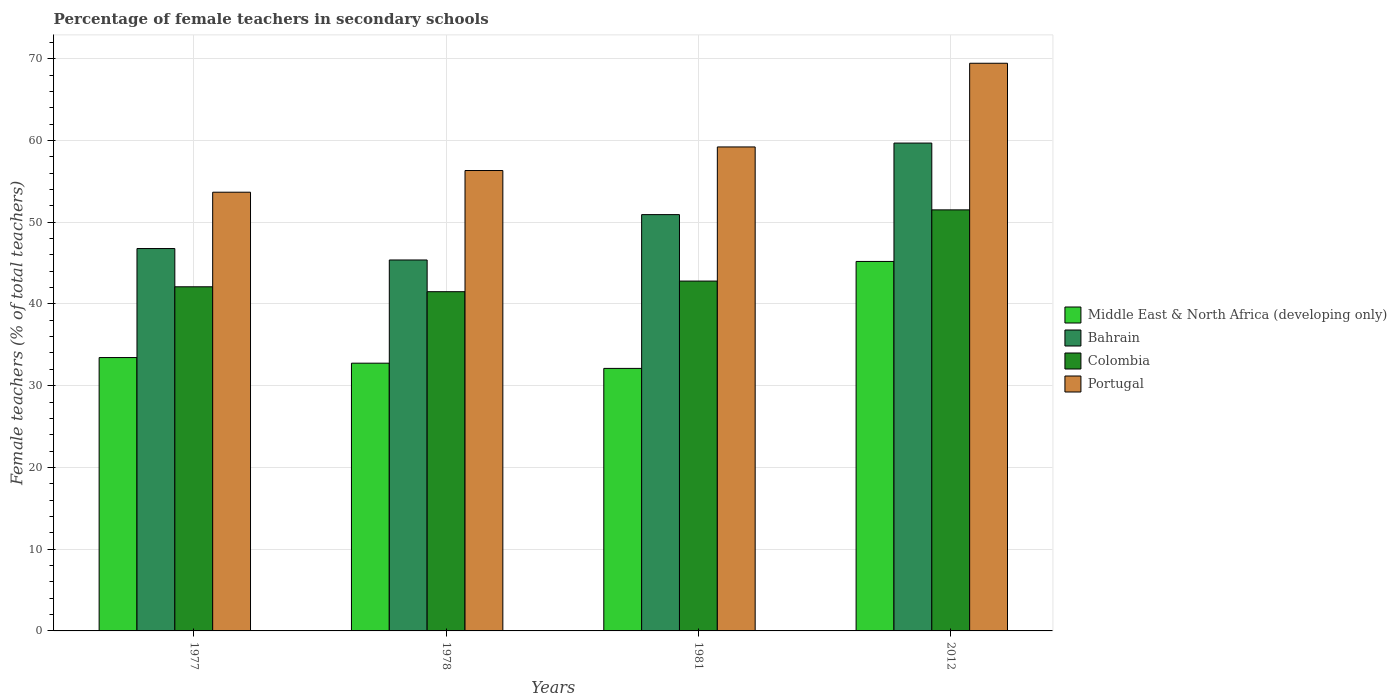How many different coloured bars are there?
Provide a succinct answer. 4. Are the number of bars per tick equal to the number of legend labels?
Provide a short and direct response. Yes. Are the number of bars on each tick of the X-axis equal?
Provide a short and direct response. Yes. How many bars are there on the 4th tick from the left?
Make the answer very short. 4. How many bars are there on the 3rd tick from the right?
Provide a succinct answer. 4. What is the label of the 2nd group of bars from the left?
Keep it short and to the point. 1978. In how many cases, is the number of bars for a given year not equal to the number of legend labels?
Your answer should be very brief. 0. What is the percentage of female teachers in Portugal in 2012?
Your answer should be compact. 69.45. Across all years, what is the maximum percentage of female teachers in Bahrain?
Your answer should be very brief. 59.68. Across all years, what is the minimum percentage of female teachers in Portugal?
Give a very brief answer. 53.67. In which year was the percentage of female teachers in Colombia maximum?
Ensure brevity in your answer.  2012. In which year was the percentage of female teachers in Colombia minimum?
Offer a very short reply. 1978. What is the total percentage of female teachers in Middle East & North Africa (developing only) in the graph?
Offer a terse response. 143.51. What is the difference between the percentage of female teachers in Colombia in 1978 and that in 2012?
Give a very brief answer. -10.01. What is the difference between the percentage of female teachers in Bahrain in 1981 and the percentage of female teachers in Portugal in 1978?
Offer a very short reply. -5.39. What is the average percentage of female teachers in Middle East & North Africa (developing only) per year?
Your answer should be very brief. 35.88. In the year 2012, what is the difference between the percentage of female teachers in Colombia and percentage of female teachers in Bahrain?
Provide a short and direct response. -8.17. In how many years, is the percentage of female teachers in Colombia greater than 30 %?
Give a very brief answer. 4. What is the ratio of the percentage of female teachers in Colombia in 1981 to that in 2012?
Make the answer very short. 0.83. Is the difference between the percentage of female teachers in Colombia in 1977 and 2012 greater than the difference between the percentage of female teachers in Bahrain in 1977 and 2012?
Give a very brief answer. Yes. What is the difference between the highest and the second highest percentage of female teachers in Portugal?
Offer a terse response. 10.24. What is the difference between the highest and the lowest percentage of female teachers in Middle East & North Africa (developing only)?
Provide a short and direct response. 13.08. Is it the case that in every year, the sum of the percentage of female teachers in Portugal and percentage of female teachers in Middle East & North Africa (developing only) is greater than the sum of percentage of female teachers in Bahrain and percentage of female teachers in Colombia?
Ensure brevity in your answer.  No. What does the 3rd bar from the left in 1981 represents?
Your answer should be compact. Colombia. Is it the case that in every year, the sum of the percentage of female teachers in Middle East & North Africa (developing only) and percentage of female teachers in Colombia is greater than the percentage of female teachers in Bahrain?
Make the answer very short. Yes. How many bars are there?
Your answer should be compact. 16. What is the difference between two consecutive major ticks on the Y-axis?
Your answer should be very brief. 10. What is the title of the graph?
Give a very brief answer. Percentage of female teachers in secondary schools. Does "Sint Maarten (Dutch part)" appear as one of the legend labels in the graph?
Keep it short and to the point. No. What is the label or title of the Y-axis?
Ensure brevity in your answer.  Female teachers (% of total teachers). What is the Female teachers (% of total teachers) of Middle East & North Africa (developing only) in 1977?
Give a very brief answer. 33.44. What is the Female teachers (% of total teachers) in Bahrain in 1977?
Your answer should be compact. 46.78. What is the Female teachers (% of total teachers) in Colombia in 1977?
Give a very brief answer. 42.1. What is the Female teachers (% of total teachers) in Portugal in 1977?
Your answer should be very brief. 53.67. What is the Female teachers (% of total teachers) of Middle East & North Africa (developing only) in 1978?
Ensure brevity in your answer.  32.75. What is the Female teachers (% of total teachers) of Bahrain in 1978?
Provide a succinct answer. 45.38. What is the Female teachers (% of total teachers) of Colombia in 1978?
Ensure brevity in your answer.  41.5. What is the Female teachers (% of total teachers) of Portugal in 1978?
Provide a short and direct response. 56.32. What is the Female teachers (% of total teachers) of Middle East & North Africa (developing only) in 1981?
Keep it short and to the point. 32.12. What is the Female teachers (% of total teachers) of Bahrain in 1981?
Your answer should be compact. 50.93. What is the Female teachers (% of total teachers) in Colombia in 1981?
Your answer should be very brief. 42.8. What is the Female teachers (% of total teachers) of Portugal in 1981?
Provide a short and direct response. 59.21. What is the Female teachers (% of total teachers) of Middle East & North Africa (developing only) in 2012?
Your answer should be compact. 45.2. What is the Female teachers (% of total teachers) of Bahrain in 2012?
Provide a short and direct response. 59.68. What is the Female teachers (% of total teachers) in Colombia in 2012?
Ensure brevity in your answer.  51.51. What is the Female teachers (% of total teachers) of Portugal in 2012?
Provide a succinct answer. 69.45. Across all years, what is the maximum Female teachers (% of total teachers) of Middle East & North Africa (developing only)?
Provide a short and direct response. 45.2. Across all years, what is the maximum Female teachers (% of total teachers) in Bahrain?
Provide a succinct answer. 59.68. Across all years, what is the maximum Female teachers (% of total teachers) of Colombia?
Provide a short and direct response. 51.51. Across all years, what is the maximum Female teachers (% of total teachers) of Portugal?
Offer a very short reply. 69.45. Across all years, what is the minimum Female teachers (% of total teachers) of Middle East & North Africa (developing only)?
Your response must be concise. 32.12. Across all years, what is the minimum Female teachers (% of total teachers) in Bahrain?
Give a very brief answer. 45.38. Across all years, what is the minimum Female teachers (% of total teachers) of Colombia?
Give a very brief answer. 41.5. Across all years, what is the minimum Female teachers (% of total teachers) in Portugal?
Provide a succinct answer. 53.67. What is the total Female teachers (% of total teachers) of Middle East & North Africa (developing only) in the graph?
Provide a short and direct response. 143.51. What is the total Female teachers (% of total teachers) of Bahrain in the graph?
Ensure brevity in your answer.  202.77. What is the total Female teachers (% of total teachers) of Colombia in the graph?
Keep it short and to the point. 177.91. What is the total Female teachers (% of total teachers) of Portugal in the graph?
Your response must be concise. 238.65. What is the difference between the Female teachers (% of total teachers) in Middle East & North Africa (developing only) in 1977 and that in 1978?
Your answer should be very brief. 0.69. What is the difference between the Female teachers (% of total teachers) of Bahrain in 1977 and that in 1978?
Your response must be concise. 1.4. What is the difference between the Female teachers (% of total teachers) of Colombia in 1977 and that in 1978?
Make the answer very short. 0.6. What is the difference between the Female teachers (% of total teachers) of Portugal in 1977 and that in 1978?
Provide a succinct answer. -2.65. What is the difference between the Female teachers (% of total teachers) in Middle East & North Africa (developing only) in 1977 and that in 1981?
Make the answer very short. 1.33. What is the difference between the Female teachers (% of total teachers) of Bahrain in 1977 and that in 1981?
Your answer should be compact. -4.15. What is the difference between the Female teachers (% of total teachers) of Colombia in 1977 and that in 1981?
Offer a very short reply. -0.7. What is the difference between the Female teachers (% of total teachers) in Portugal in 1977 and that in 1981?
Give a very brief answer. -5.54. What is the difference between the Female teachers (% of total teachers) in Middle East & North Africa (developing only) in 1977 and that in 2012?
Give a very brief answer. -11.76. What is the difference between the Female teachers (% of total teachers) of Bahrain in 1977 and that in 2012?
Ensure brevity in your answer.  -12.9. What is the difference between the Female teachers (% of total teachers) of Colombia in 1977 and that in 2012?
Your response must be concise. -9.41. What is the difference between the Female teachers (% of total teachers) in Portugal in 1977 and that in 2012?
Make the answer very short. -15.78. What is the difference between the Female teachers (% of total teachers) of Middle East & North Africa (developing only) in 1978 and that in 1981?
Make the answer very short. 0.64. What is the difference between the Female teachers (% of total teachers) in Bahrain in 1978 and that in 1981?
Offer a terse response. -5.55. What is the difference between the Female teachers (% of total teachers) in Colombia in 1978 and that in 1981?
Offer a very short reply. -1.3. What is the difference between the Female teachers (% of total teachers) of Portugal in 1978 and that in 1981?
Offer a terse response. -2.88. What is the difference between the Female teachers (% of total teachers) in Middle East & North Africa (developing only) in 1978 and that in 2012?
Offer a very short reply. -12.44. What is the difference between the Female teachers (% of total teachers) of Bahrain in 1978 and that in 2012?
Your answer should be very brief. -14.3. What is the difference between the Female teachers (% of total teachers) in Colombia in 1978 and that in 2012?
Your answer should be compact. -10.01. What is the difference between the Female teachers (% of total teachers) in Portugal in 1978 and that in 2012?
Your answer should be very brief. -13.12. What is the difference between the Female teachers (% of total teachers) in Middle East & North Africa (developing only) in 1981 and that in 2012?
Make the answer very short. -13.08. What is the difference between the Female teachers (% of total teachers) of Bahrain in 1981 and that in 2012?
Make the answer very short. -8.75. What is the difference between the Female teachers (% of total teachers) of Colombia in 1981 and that in 2012?
Keep it short and to the point. -8.71. What is the difference between the Female teachers (% of total teachers) of Portugal in 1981 and that in 2012?
Provide a succinct answer. -10.24. What is the difference between the Female teachers (% of total teachers) of Middle East & North Africa (developing only) in 1977 and the Female teachers (% of total teachers) of Bahrain in 1978?
Offer a terse response. -11.94. What is the difference between the Female teachers (% of total teachers) in Middle East & North Africa (developing only) in 1977 and the Female teachers (% of total teachers) in Colombia in 1978?
Your answer should be very brief. -8.06. What is the difference between the Female teachers (% of total teachers) of Middle East & North Africa (developing only) in 1977 and the Female teachers (% of total teachers) of Portugal in 1978?
Keep it short and to the point. -22.88. What is the difference between the Female teachers (% of total teachers) of Bahrain in 1977 and the Female teachers (% of total teachers) of Colombia in 1978?
Make the answer very short. 5.28. What is the difference between the Female teachers (% of total teachers) of Bahrain in 1977 and the Female teachers (% of total teachers) of Portugal in 1978?
Your answer should be compact. -9.55. What is the difference between the Female teachers (% of total teachers) in Colombia in 1977 and the Female teachers (% of total teachers) in Portugal in 1978?
Ensure brevity in your answer.  -14.22. What is the difference between the Female teachers (% of total teachers) in Middle East & North Africa (developing only) in 1977 and the Female teachers (% of total teachers) in Bahrain in 1981?
Offer a very short reply. -17.49. What is the difference between the Female teachers (% of total teachers) in Middle East & North Africa (developing only) in 1977 and the Female teachers (% of total teachers) in Colombia in 1981?
Provide a succinct answer. -9.36. What is the difference between the Female teachers (% of total teachers) in Middle East & North Africa (developing only) in 1977 and the Female teachers (% of total teachers) in Portugal in 1981?
Provide a short and direct response. -25.77. What is the difference between the Female teachers (% of total teachers) of Bahrain in 1977 and the Female teachers (% of total teachers) of Colombia in 1981?
Offer a very short reply. 3.98. What is the difference between the Female teachers (% of total teachers) in Bahrain in 1977 and the Female teachers (% of total teachers) in Portugal in 1981?
Provide a short and direct response. -12.43. What is the difference between the Female teachers (% of total teachers) in Colombia in 1977 and the Female teachers (% of total teachers) in Portugal in 1981?
Ensure brevity in your answer.  -17.11. What is the difference between the Female teachers (% of total teachers) of Middle East & North Africa (developing only) in 1977 and the Female teachers (% of total teachers) of Bahrain in 2012?
Your answer should be very brief. -26.24. What is the difference between the Female teachers (% of total teachers) in Middle East & North Africa (developing only) in 1977 and the Female teachers (% of total teachers) in Colombia in 2012?
Your answer should be very brief. -18.07. What is the difference between the Female teachers (% of total teachers) in Middle East & North Africa (developing only) in 1977 and the Female teachers (% of total teachers) in Portugal in 2012?
Make the answer very short. -36. What is the difference between the Female teachers (% of total teachers) of Bahrain in 1977 and the Female teachers (% of total teachers) of Colombia in 2012?
Give a very brief answer. -4.73. What is the difference between the Female teachers (% of total teachers) of Bahrain in 1977 and the Female teachers (% of total teachers) of Portugal in 2012?
Offer a very short reply. -22.67. What is the difference between the Female teachers (% of total teachers) of Colombia in 1977 and the Female teachers (% of total teachers) of Portugal in 2012?
Make the answer very short. -27.35. What is the difference between the Female teachers (% of total teachers) in Middle East & North Africa (developing only) in 1978 and the Female teachers (% of total teachers) in Bahrain in 1981?
Keep it short and to the point. -18.17. What is the difference between the Female teachers (% of total teachers) in Middle East & North Africa (developing only) in 1978 and the Female teachers (% of total teachers) in Colombia in 1981?
Your answer should be very brief. -10.04. What is the difference between the Female teachers (% of total teachers) in Middle East & North Africa (developing only) in 1978 and the Female teachers (% of total teachers) in Portugal in 1981?
Keep it short and to the point. -26.45. What is the difference between the Female teachers (% of total teachers) in Bahrain in 1978 and the Female teachers (% of total teachers) in Colombia in 1981?
Provide a short and direct response. 2.58. What is the difference between the Female teachers (% of total teachers) of Bahrain in 1978 and the Female teachers (% of total teachers) of Portugal in 1981?
Ensure brevity in your answer.  -13.83. What is the difference between the Female teachers (% of total teachers) of Colombia in 1978 and the Female teachers (% of total teachers) of Portugal in 1981?
Offer a very short reply. -17.71. What is the difference between the Female teachers (% of total teachers) in Middle East & North Africa (developing only) in 1978 and the Female teachers (% of total teachers) in Bahrain in 2012?
Keep it short and to the point. -26.93. What is the difference between the Female teachers (% of total teachers) in Middle East & North Africa (developing only) in 1978 and the Female teachers (% of total teachers) in Colombia in 2012?
Keep it short and to the point. -18.75. What is the difference between the Female teachers (% of total teachers) in Middle East & North Africa (developing only) in 1978 and the Female teachers (% of total teachers) in Portugal in 2012?
Provide a short and direct response. -36.69. What is the difference between the Female teachers (% of total teachers) of Bahrain in 1978 and the Female teachers (% of total teachers) of Colombia in 2012?
Keep it short and to the point. -6.13. What is the difference between the Female teachers (% of total teachers) in Bahrain in 1978 and the Female teachers (% of total teachers) in Portugal in 2012?
Your answer should be compact. -24.07. What is the difference between the Female teachers (% of total teachers) in Colombia in 1978 and the Female teachers (% of total teachers) in Portugal in 2012?
Offer a very short reply. -27.95. What is the difference between the Female teachers (% of total teachers) in Middle East & North Africa (developing only) in 1981 and the Female teachers (% of total teachers) in Bahrain in 2012?
Offer a very short reply. -27.56. What is the difference between the Female teachers (% of total teachers) of Middle East & North Africa (developing only) in 1981 and the Female teachers (% of total teachers) of Colombia in 2012?
Ensure brevity in your answer.  -19.39. What is the difference between the Female teachers (% of total teachers) in Middle East & North Africa (developing only) in 1981 and the Female teachers (% of total teachers) in Portugal in 2012?
Your answer should be very brief. -37.33. What is the difference between the Female teachers (% of total teachers) in Bahrain in 1981 and the Female teachers (% of total teachers) in Colombia in 2012?
Your answer should be very brief. -0.58. What is the difference between the Female teachers (% of total teachers) in Bahrain in 1981 and the Female teachers (% of total teachers) in Portugal in 2012?
Your answer should be compact. -18.52. What is the difference between the Female teachers (% of total teachers) in Colombia in 1981 and the Female teachers (% of total teachers) in Portugal in 2012?
Your response must be concise. -26.65. What is the average Female teachers (% of total teachers) in Middle East & North Africa (developing only) per year?
Keep it short and to the point. 35.88. What is the average Female teachers (% of total teachers) of Bahrain per year?
Provide a succinct answer. 50.69. What is the average Female teachers (% of total teachers) in Colombia per year?
Provide a short and direct response. 44.48. What is the average Female teachers (% of total teachers) of Portugal per year?
Your answer should be compact. 59.66. In the year 1977, what is the difference between the Female teachers (% of total teachers) of Middle East & North Africa (developing only) and Female teachers (% of total teachers) of Bahrain?
Offer a very short reply. -13.34. In the year 1977, what is the difference between the Female teachers (% of total teachers) in Middle East & North Africa (developing only) and Female teachers (% of total teachers) in Colombia?
Keep it short and to the point. -8.66. In the year 1977, what is the difference between the Female teachers (% of total teachers) in Middle East & North Africa (developing only) and Female teachers (% of total teachers) in Portugal?
Give a very brief answer. -20.23. In the year 1977, what is the difference between the Female teachers (% of total teachers) of Bahrain and Female teachers (% of total teachers) of Colombia?
Make the answer very short. 4.68. In the year 1977, what is the difference between the Female teachers (% of total teachers) in Bahrain and Female teachers (% of total teachers) in Portugal?
Offer a terse response. -6.89. In the year 1977, what is the difference between the Female teachers (% of total teachers) in Colombia and Female teachers (% of total teachers) in Portugal?
Your answer should be very brief. -11.57. In the year 1978, what is the difference between the Female teachers (% of total teachers) of Middle East & North Africa (developing only) and Female teachers (% of total teachers) of Bahrain?
Keep it short and to the point. -12.62. In the year 1978, what is the difference between the Female teachers (% of total teachers) of Middle East & North Africa (developing only) and Female teachers (% of total teachers) of Colombia?
Your answer should be very brief. -8.74. In the year 1978, what is the difference between the Female teachers (% of total teachers) in Middle East & North Africa (developing only) and Female teachers (% of total teachers) in Portugal?
Give a very brief answer. -23.57. In the year 1978, what is the difference between the Female teachers (% of total teachers) in Bahrain and Female teachers (% of total teachers) in Colombia?
Provide a succinct answer. 3.88. In the year 1978, what is the difference between the Female teachers (% of total teachers) of Bahrain and Female teachers (% of total teachers) of Portugal?
Keep it short and to the point. -10.94. In the year 1978, what is the difference between the Female teachers (% of total teachers) of Colombia and Female teachers (% of total teachers) of Portugal?
Give a very brief answer. -14.82. In the year 1981, what is the difference between the Female teachers (% of total teachers) in Middle East & North Africa (developing only) and Female teachers (% of total teachers) in Bahrain?
Provide a short and direct response. -18.81. In the year 1981, what is the difference between the Female teachers (% of total teachers) in Middle East & North Africa (developing only) and Female teachers (% of total teachers) in Colombia?
Offer a terse response. -10.68. In the year 1981, what is the difference between the Female teachers (% of total teachers) in Middle East & North Africa (developing only) and Female teachers (% of total teachers) in Portugal?
Your answer should be compact. -27.09. In the year 1981, what is the difference between the Female teachers (% of total teachers) in Bahrain and Female teachers (% of total teachers) in Colombia?
Your answer should be very brief. 8.13. In the year 1981, what is the difference between the Female teachers (% of total teachers) in Bahrain and Female teachers (% of total teachers) in Portugal?
Provide a short and direct response. -8.28. In the year 1981, what is the difference between the Female teachers (% of total teachers) of Colombia and Female teachers (% of total teachers) of Portugal?
Offer a terse response. -16.41. In the year 2012, what is the difference between the Female teachers (% of total teachers) of Middle East & North Africa (developing only) and Female teachers (% of total teachers) of Bahrain?
Your response must be concise. -14.48. In the year 2012, what is the difference between the Female teachers (% of total teachers) of Middle East & North Africa (developing only) and Female teachers (% of total teachers) of Colombia?
Provide a short and direct response. -6.31. In the year 2012, what is the difference between the Female teachers (% of total teachers) in Middle East & North Africa (developing only) and Female teachers (% of total teachers) in Portugal?
Give a very brief answer. -24.25. In the year 2012, what is the difference between the Female teachers (% of total teachers) of Bahrain and Female teachers (% of total teachers) of Colombia?
Your answer should be very brief. 8.17. In the year 2012, what is the difference between the Female teachers (% of total teachers) of Bahrain and Female teachers (% of total teachers) of Portugal?
Provide a succinct answer. -9.76. In the year 2012, what is the difference between the Female teachers (% of total teachers) in Colombia and Female teachers (% of total teachers) in Portugal?
Make the answer very short. -17.94. What is the ratio of the Female teachers (% of total teachers) in Middle East & North Africa (developing only) in 1977 to that in 1978?
Your answer should be very brief. 1.02. What is the ratio of the Female teachers (% of total teachers) of Bahrain in 1977 to that in 1978?
Your answer should be compact. 1.03. What is the ratio of the Female teachers (% of total teachers) of Colombia in 1977 to that in 1978?
Provide a short and direct response. 1.01. What is the ratio of the Female teachers (% of total teachers) of Portugal in 1977 to that in 1978?
Provide a short and direct response. 0.95. What is the ratio of the Female teachers (% of total teachers) in Middle East & North Africa (developing only) in 1977 to that in 1981?
Your answer should be compact. 1.04. What is the ratio of the Female teachers (% of total teachers) in Bahrain in 1977 to that in 1981?
Provide a succinct answer. 0.92. What is the ratio of the Female teachers (% of total teachers) in Colombia in 1977 to that in 1981?
Your answer should be compact. 0.98. What is the ratio of the Female teachers (% of total teachers) in Portugal in 1977 to that in 1981?
Make the answer very short. 0.91. What is the ratio of the Female teachers (% of total teachers) of Middle East & North Africa (developing only) in 1977 to that in 2012?
Offer a terse response. 0.74. What is the ratio of the Female teachers (% of total teachers) in Bahrain in 1977 to that in 2012?
Keep it short and to the point. 0.78. What is the ratio of the Female teachers (% of total teachers) in Colombia in 1977 to that in 2012?
Offer a terse response. 0.82. What is the ratio of the Female teachers (% of total teachers) of Portugal in 1977 to that in 2012?
Your answer should be very brief. 0.77. What is the ratio of the Female teachers (% of total teachers) in Middle East & North Africa (developing only) in 1978 to that in 1981?
Your answer should be very brief. 1.02. What is the ratio of the Female teachers (% of total teachers) in Bahrain in 1978 to that in 1981?
Your answer should be compact. 0.89. What is the ratio of the Female teachers (% of total teachers) in Colombia in 1978 to that in 1981?
Give a very brief answer. 0.97. What is the ratio of the Female teachers (% of total teachers) of Portugal in 1978 to that in 1981?
Give a very brief answer. 0.95. What is the ratio of the Female teachers (% of total teachers) in Middle East & North Africa (developing only) in 1978 to that in 2012?
Make the answer very short. 0.72. What is the ratio of the Female teachers (% of total teachers) of Bahrain in 1978 to that in 2012?
Offer a terse response. 0.76. What is the ratio of the Female teachers (% of total teachers) in Colombia in 1978 to that in 2012?
Your answer should be compact. 0.81. What is the ratio of the Female teachers (% of total teachers) of Portugal in 1978 to that in 2012?
Your answer should be very brief. 0.81. What is the ratio of the Female teachers (% of total teachers) of Middle East & North Africa (developing only) in 1981 to that in 2012?
Ensure brevity in your answer.  0.71. What is the ratio of the Female teachers (% of total teachers) in Bahrain in 1981 to that in 2012?
Keep it short and to the point. 0.85. What is the ratio of the Female teachers (% of total teachers) in Colombia in 1981 to that in 2012?
Provide a succinct answer. 0.83. What is the ratio of the Female teachers (% of total teachers) in Portugal in 1981 to that in 2012?
Make the answer very short. 0.85. What is the difference between the highest and the second highest Female teachers (% of total teachers) of Middle East & North Africa (developing only)?
Make the answer very short. 11.76. What is the difference between the highest and the second highest Female teachers (% of total teachers) in Bahrain?
Your answer should be very brief. 8.75. What is the difference between the highest and the second highest Female teachers (% of total teachers) of Colombia?
Make the answer very short. 8.71. What is the difference between the highest and the second highest Female teachers (% of total teachers) of Portugal?
Offer a terse response. 10.24. What is the difference between the highest and the lowest Female teachers (% of total teachers) of Middle East & North Africa (developing only)?
Your response must be concise. 13.08. What is the difference between the highest and the lowest Female teachers (% of total teachers) in Bahrain?
Your answer should be very brief. 14.3. What is the difference between the highest and the lowest Female teachers (% of total teachers) in Colombia?
Your answer should be compact. 10.01. What is the difference between the highest and the lowest Female teachers (% of total teachers) in Portugal?
Ensure brevity in your answer.  15.78. 